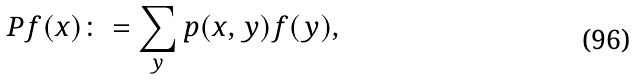<formula> <loc_0><loc_0><loc_500><loc_500>P f ( x ) \colon = \sum _ { y } p ( x , y ) f ( y ) ,</formula> 